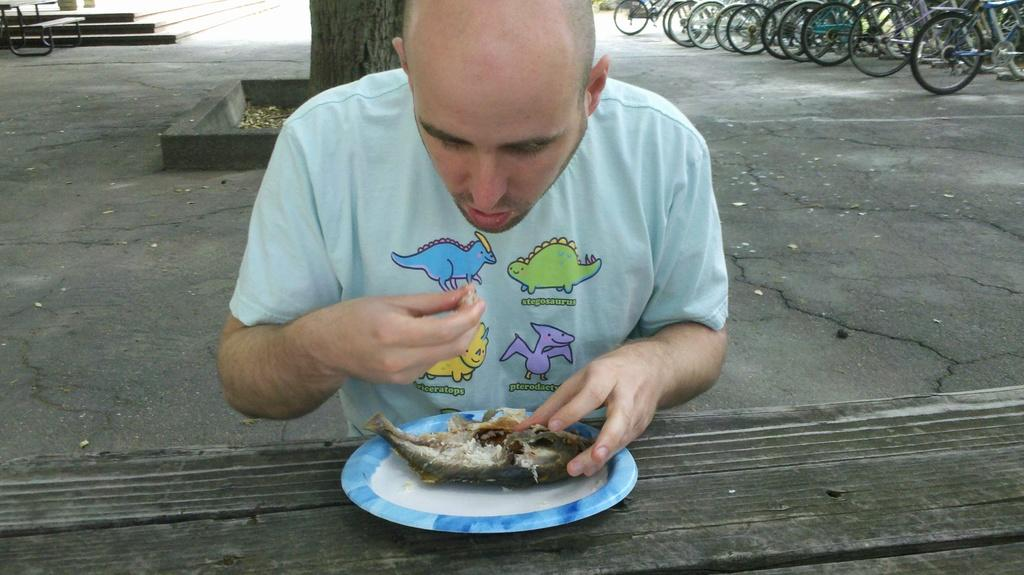What are the people in the image doing? There are persons sitting at the table in the image. What is on the plate that is on the table? There is a plate with fish on the table. What can be seen in the background of the image? There are cycles, a tree, and stairs in the background of the image. What type of flowers are being played by the band in the image? There is no band present in the image, so there are no flowers being played by a band. 